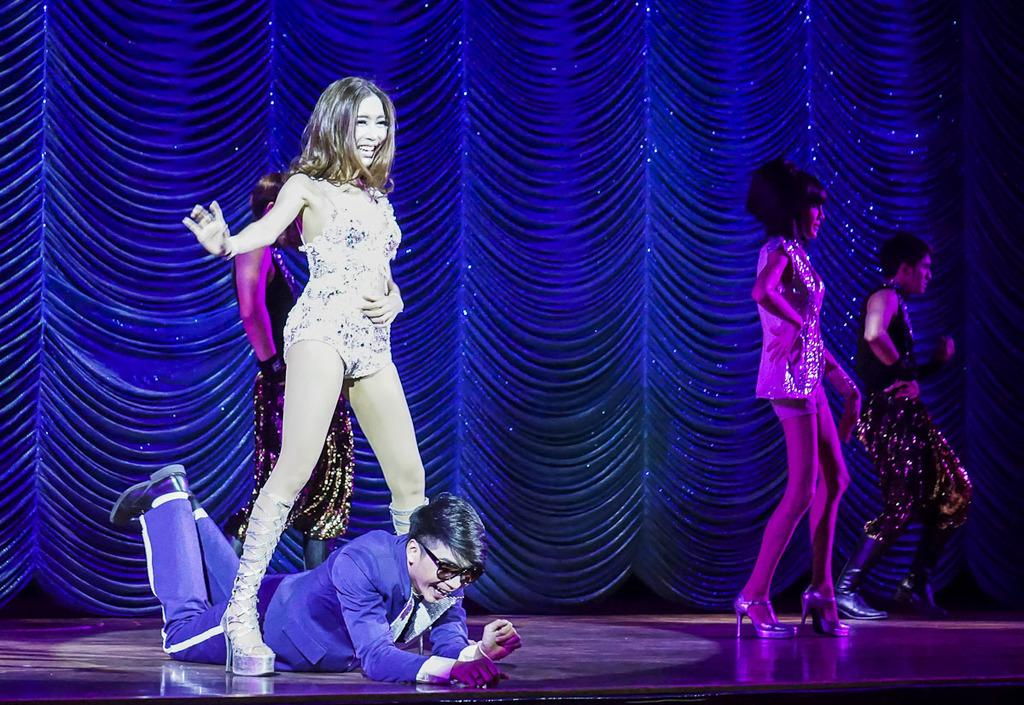What is the man in the image doing? The man is lying on the floor in the image. What are the other people in the image doing? There are people dancing on the floor in the image. What can be seen in the background of the image? There is a curtain visible in the background of the image. How many roses are hanging from the cobweb in the morning in the image? There is no cobweb, rose, or morning mentioned in the image. The image only shows a man lying on the floor and people dancing, with a curtain visible in the background. 